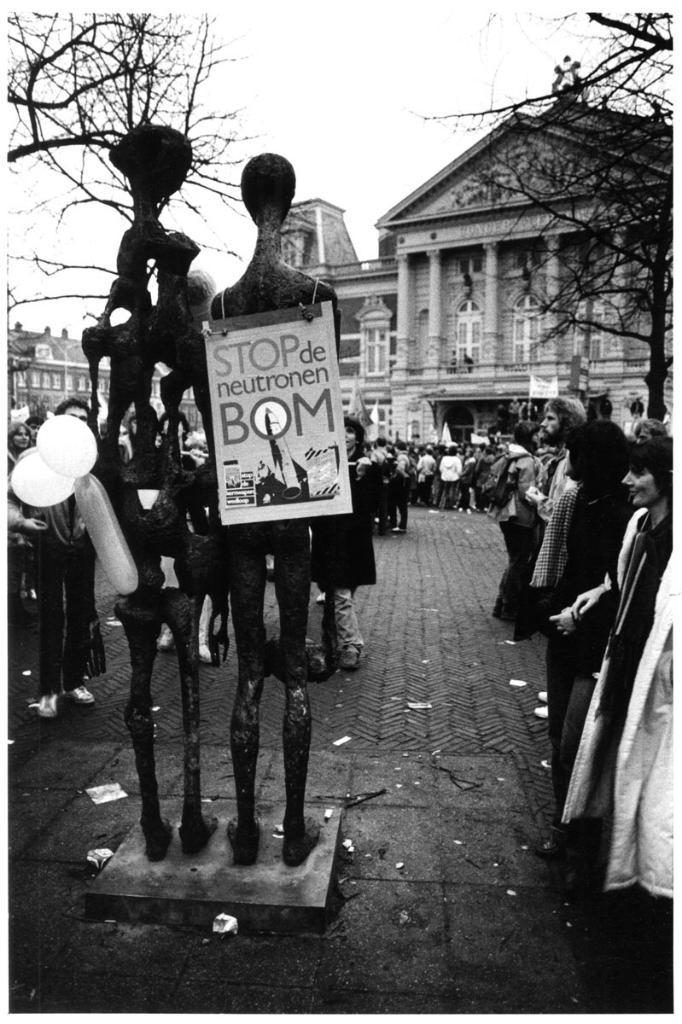Please provide a concise description of this image. This image is a black and white image. This image is taken outdoors. At the top of the there is the sky. In the background there are a few buildings with walls, windows, pillars, doors, roofs, balconies and railings. There is a text on a wall. There are a few trees. In the middle of the image there are two statues on the floor and there is a board with a text on it. In this image many people are standing on the floor there are two balloons. 